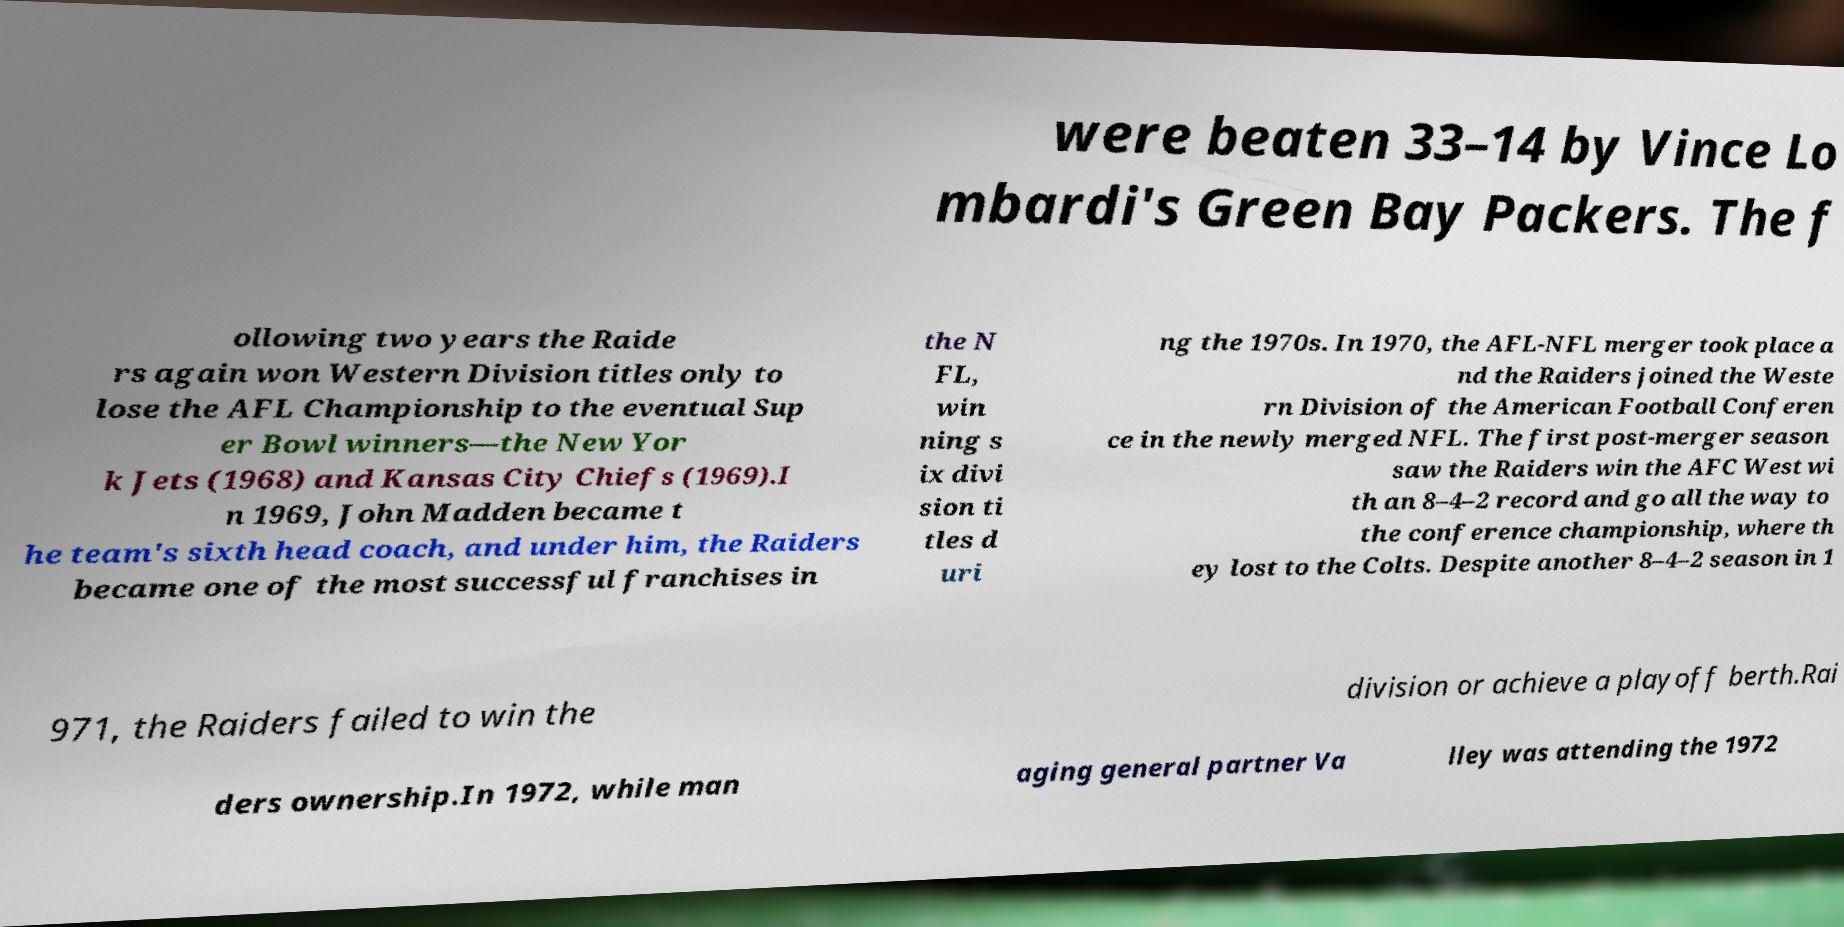Can you accurately transcribe the text from the provided image for me? were beaten 33–14 by Vince Lo mbardi's Green Bay Packers. The f ollowing two years the Raide rs again won Western Division titles only to lose the AFL Championship to the eventual Sup er Bowl winners—the New Yor k Jets (1968) and Kansas City Chiefs (1969).I n 1969, John Madden became t he team's sixth head coach, and under him, the Raiders became one of the most successful franchises in the N FL, win ning s ix divi sion ti tles d uri ng the 1970s. In 1970, the AFL-NFL merger took place a nd the Raiders joined the Weste rn Division of the American Football Conferen ce in the newly merged NFL. The first post-merger season saw the Raiders win the AFC West wi th an 8–4–2 record and go all the way to the conference championship, where th ey lost to the Colts. Despite another 8–4–2 season in 1 971, the Raiders failed to win the division or achieve a playoff berth.Rai ders ownership.In 1972, while man aging general partner Va lley was attending the 1972 